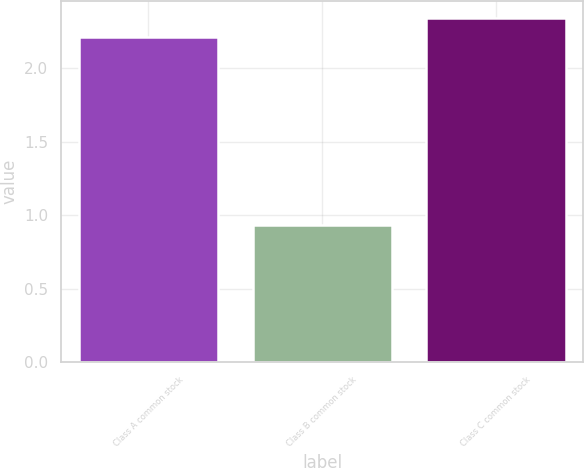<chart> <loc_0><loc_0><loc_500><loc_500><bar_chart><fcel>Class A common stock<fcel>Class B common stock<fcel>Class C common stock<nl><fcel>2.21<fcel>0.93<fcel>2.34<nl></chart> 